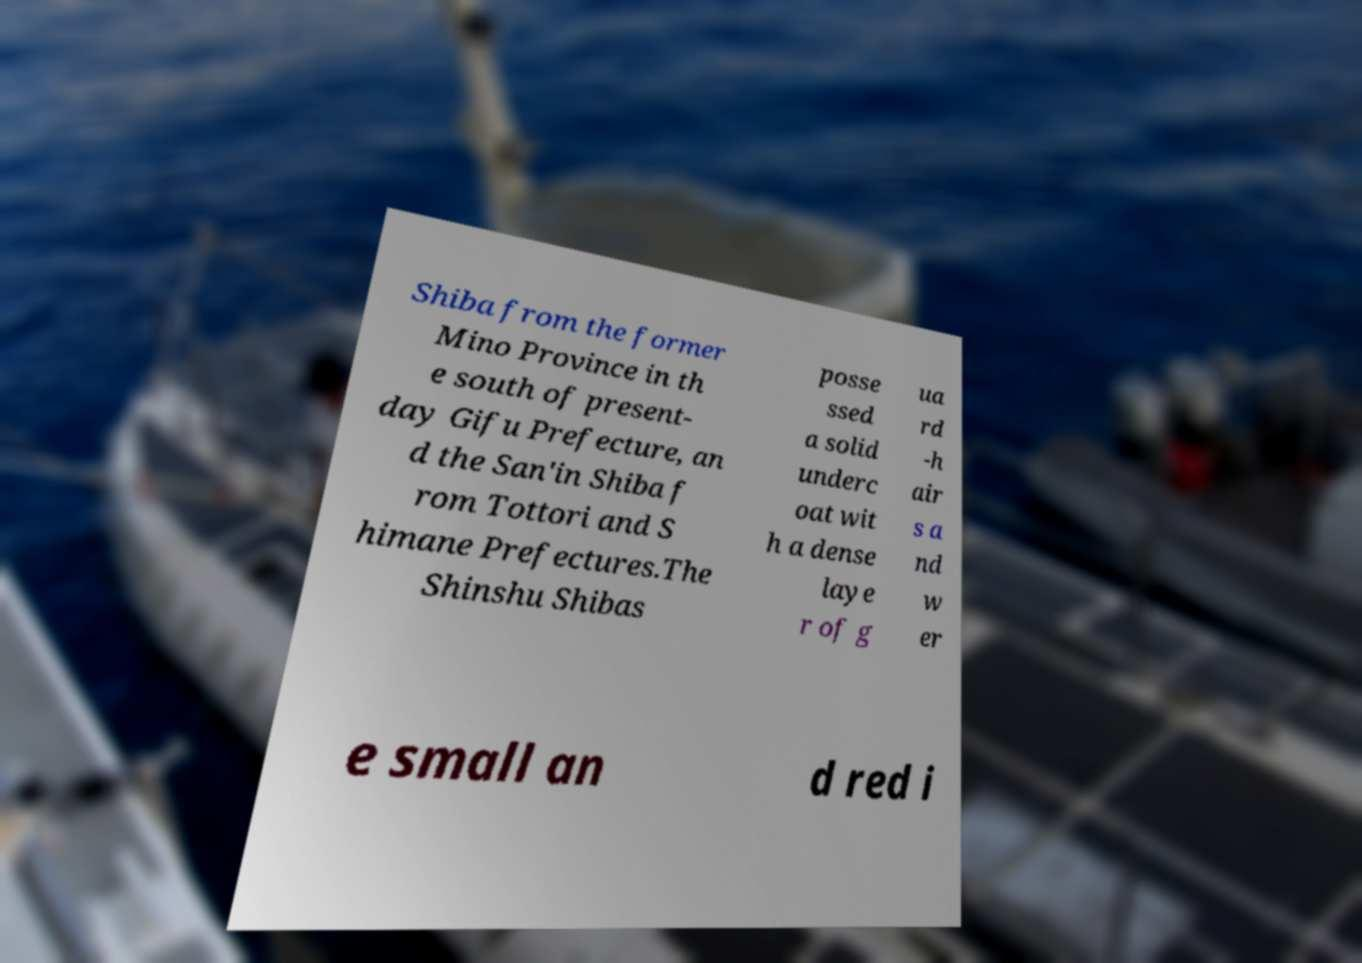Please identify and transcribe the text found in this image. Shiba from the former Mino Province in th e south of present- day Gifu Prefecture, an d the San'in Shiba f rom Tottori and S himane Prefectures.The Shinshu Shibas posse ssed a solid underc oat wit h a dense laye r of g ua rd -h air s a nd w er e small an d red i 